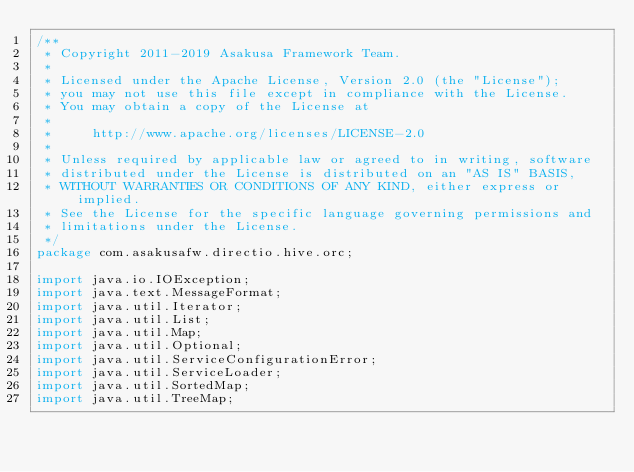Convert code to text. <code><loc_0><loc_0><loc_500><loc_500><_Java_>/**
 * Copyright 2011-2019 Asakusa Framework Team.
 *
 * Licensed under the Apache License, Version 2.0 (the "License");
 * you may not use this file except in compliance with the License.
 * You may obtain a copy of the License at
 *
 *     http://www.apache.org/licenses/LICENSE-2.0
 *
 * Unless required by applicable law or agreed to in writing, software
 * distributed under the License is distributed on an "AS IS" BASIS,
 * WITHOUT WARRANTIES OR CONDITIONS OF ANY KIND, either express or implied.
 * See the License for the specific language governing permissions and
 * limitations under the License.
 */
package com.asakusafw.directio.hive.orc;

import java.io.IOException;
import java.text.MessageFormat;
import java.util.Iterator;
import java.util.List;
import java.util.Map;
import java.util.Optional;
import java.util.ServiceConfigurationError;
import java.util.ServiceLoader;
import java.util.SortedMap;
import java.util.TreeMap;
</code> 